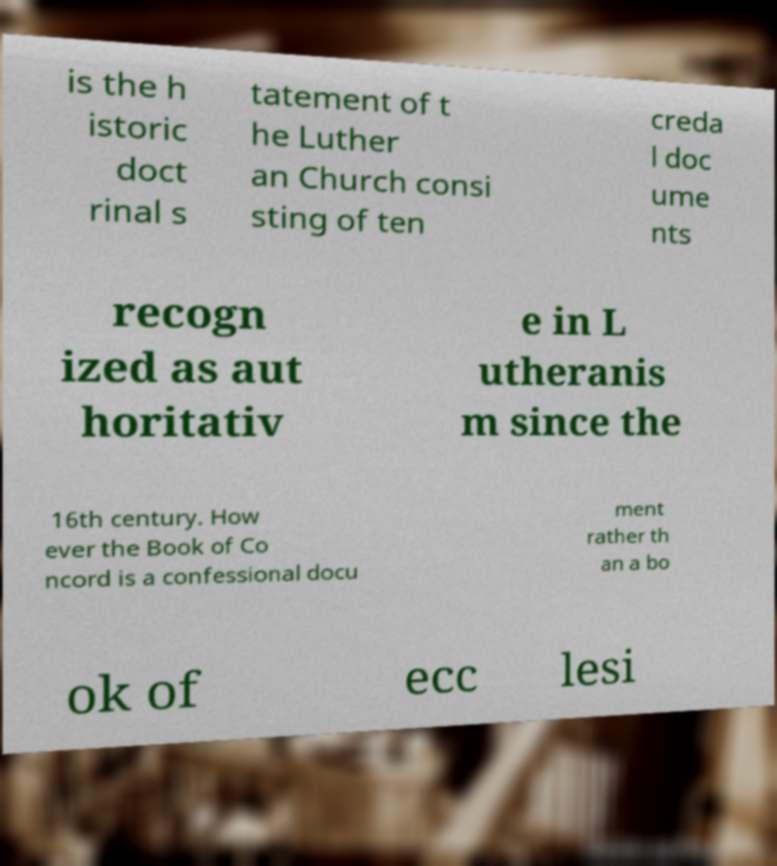Could you extract and type out the text from this image? is the h istoric doct rinal s tatement of t he Luther an Church consi sting of ten creda l doc ume nts recogn ized as aut horitativ e in L utheranis m since the 16th century. How ever the Book of Co ncord is a confessional docu ment rather th an a bo ok of ecc lesi 